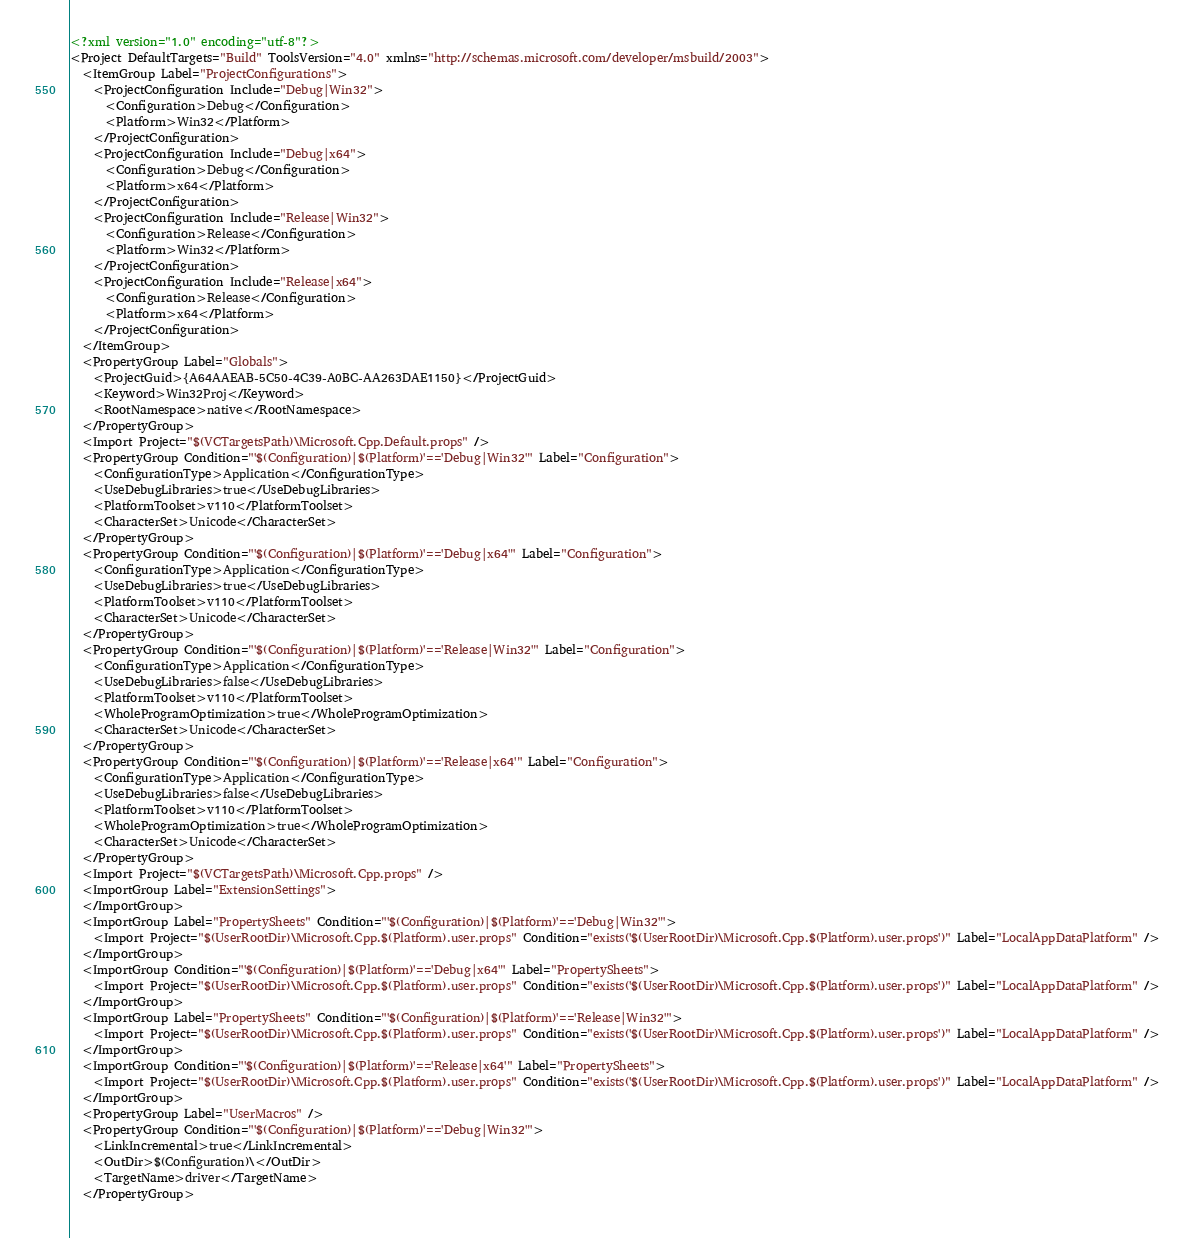Convert code to text. <code><loc_0><loc_0><loc_500><loc_500><_XML_><?xml version="1.0" encoding="utf-8"?>
<Project DefaultTargets="Build" ToolsVersion="4.0" xmlns="http://schemas.microsoft.com/developer/msbuild/2003">
  <ItemGroup Label="ProjectConfigurations">
    <ProjectConfiguration Include="Debug|Win32">
      <Configuration>Debug</Configuration>
      <Platform>Win32</Platform>
    </ProjectConfiguration>
    <ProjectConfiguration Include="Debug|x64">
      <Configuration>Debug</Configuration>
      <Platform>x64</Platform>
    </ProjectConfiguration>
    <ProjectConfiguration Include="Release|Win32">
      <Configuration>Release</Configuration>
      <Platform>Win32</Platform>
    </ProjectConfiguration>
    <ProjectConfiguration Include="Release|x64">
      <Configuration>Release</Configuration>
      <Platform>x64</Platform>
    </ProjectConfiguration>
  </ItemGroup>
  <PropertyGroup Label="Globals">
    <ProjectGuid>{A64AAEAB-5C50-4C39-A0BC-AA263DAE1150}</ProjectGuid>
    <Keyword>Win32Proj</Keyword>
    <RootNamespace>native</RootNamespace>
  </PropertyGroup>
  <Import Project="$(VCTargetsPath)\Microsoft.Cpp.Default.props" />
  <PropertyGroup Condition="'$(Configuration)|$(Platform)'=='Debug|Win32'" Label="Configuration">
    <ConfigurationType>Application</ConfigurationType>
    <UseDebugLibraries>true</UseDebugLibraries>
    <PlatformToolset>v110</PlatformToolset>
    <CharacterSet>Unicode</CharacterSet>
  </PropertyGroup>
  <PropertyGroup Condition="'$(Configuration)|$(Platform)'=='Debug|x64'" Label="Configuration">
    <ConfigurationType>Application</ConfigurationType>
    <UseDebugLibraries>true</UseDebugLibraries>
    <PlatformToolset>v110</PlatformToolset>
    <CharacterSet>Unicode</CharacterSet>
  </PropertyGroup>
  <PropertyGroup Condition="'$(Configuration)|$(Platform)'=='Release|Win32'" Label="Configuration">
    <ConfigurationType>Application</ConfigurationType>
    <UseDebugLibraries>false</UseDebugLibraries>
    <PlatformToolset>v110</PlatformToolset>
    <WholeProgramOptimization>true</WholeProgramOptimization>
    <CharacterSet>Unicode</CharacterSet>
  </PropertyGroup>
  <PropertyGroup Condition="'$(Configuration)|$(Platform)'=='Release|x64'" Label="Configuration">
    <ConfigurationType>Application</ConfigurationType>
    <UseDebugLibraries>false</UseDebugLibraries>
    <PlatformToolset>v110</PlatformToolset>
    <WholeProgramOptimization>true</WholeProgramOptimization>
    <CharacterSet>Unicode</CharacterSet>
  </PropertyGroup>
  <Import Project="$(VCTargetsPath)\Microsoft.Cpp.props" />
  <ImportGroup Label="ExtensionSettings">
  </ImportGroup>
  <ImportGroup Label="PropertySheets" Condition="'$(Configuration)|$(Platform)'=='Debug|Win32'">
    <Import Project="$(UserRootDir)\Microsoft.Cpp.$(Platform).user.props" Condition="exists('$(UserRootDir)\Microsoft.Cpp.$(Platform).user.props')" Label="LocalAppDataPlatform" />
  </ImportGroup>
  <ImportGroup Condition="'$(Configuration)|$(Platform)'=='Debug|x64'" Label="PropertySheets">
    <Import Project="$(UserRootDir)\Microsoft.Cpp.$(Platform).user.props" Condition="exists('$(UserRootDir)\Microsoft.Cpp.$(Platform).user.props')" Label="LocalAppDataPlatform" />
  </ImportGroup>
  <ImportGroup Label="PropertySheets" Condition="'$(Configuration)|$(Platform)'=='Release|Win32'">
    <Import Project="$(UserRootDir)\Microsoft.Cpp.$(Platform).user.props" Condition="exists('$(UserRootDir)\Microsoft.Cpp.$(Platform).user.props')" Label="LocalAppDataPlatform" />
  </ImportGroup>
  <ImportGroup Condition="'$(Configuration)|$(Platform)'=='Release|x64'" Label="PropertySheets">
    <Import Project="$(UserRootDir)\Microsoft.Cpp.$(Platform).user.props" Condition="exists('$(UserRootDir)\Microsoft.Cpp.$(Platform).user.props')" Label="LocalAppDataPlatform" />
  </ImportGroup>
  <PropertyGroup Label="UserMacros" />
  <PropertyGroup Condition="'$(Configuration)|$(Platform)'=='Debug|Win32'">
    <LinkIncremental>true</LinkIncremental>
    <OutDir>$(Configuration)\</OutDir>
    <TargetName>driver</TargetName>
  </PropertyGroup></code> 